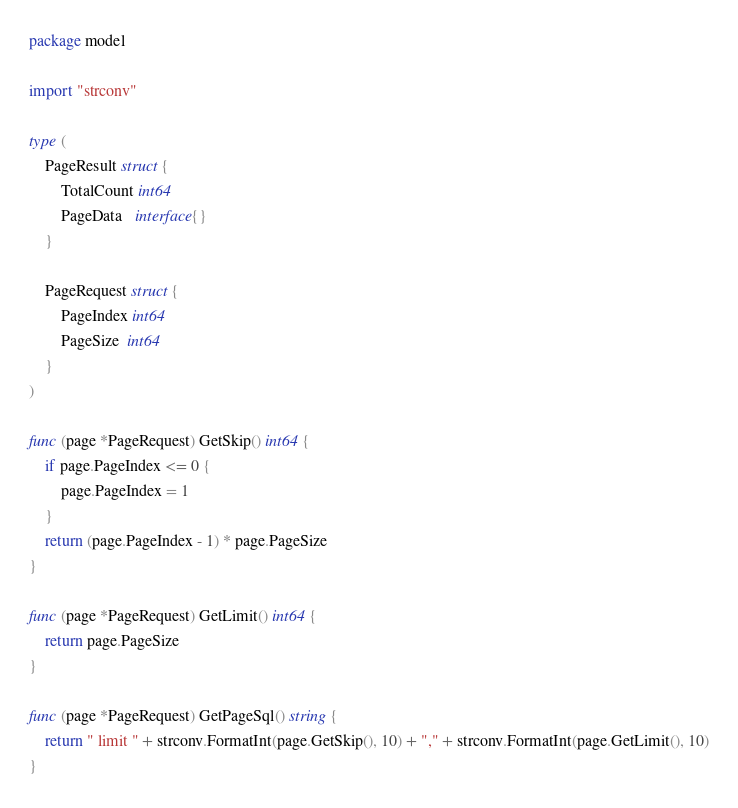Convert code to text. <code><loc_0><loc_0><loc_500><loc_500><_Go_>package model

import "strconv"

type (
	PageResult struct {
		TotalCount int64
		PageData   interface{}
	}

	PageRequest struct {
		PageIndex int64
		PageSize  int64
	}
)

func (page *PageRequest) GetSkip() int64 {
	if page.PageIndex <= 0 {
		page.PageIndex = 1
	}
	return (page.PageIndex - 1) * page.PageSize
}

func (page *PageRequest) GetLimit() int64 {
	return page.PageSize
}

func (page *PageRequest) GetPageSql() string {
	return " limit " + strconv.FormatInt(page.GetSkip(), 10) + "," + strconv.FormatInt(page.GetLimit(), 10)
}
</code> 